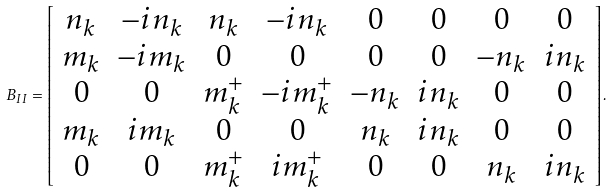Convert formula to latex. <formula><loc_0><loc_0><loc_500><loc_500>B _ { I I } = \left [ \begin{array} { c c c c c c c c } n _ { k } & - i n _ { k } & n _ { k } & - i n _ { k } & 0 & 0 & 0 & 0 \\ m _ { k } & - i m _ { k } & 0 & 0 & 0 & 0 & - n _ { k } & i n _ { k } \\ 0 & 0 & m _ { k } ^ { + } & - i m _ { k } ^ { + } & - n _ { k } & i n _ { k } & 0 & 0 \\ m _ { k } & i m _ { k } & 0 & 0 & n _ { k } & i n _ { k } & 0 & 0 \\ 0 & 0 & m _ { k } ^ { + } & i m _ { k } ^ { + } & 0 & 0 & n _ { k } & i n _ { k } \end{array} \right ] .</formula> 